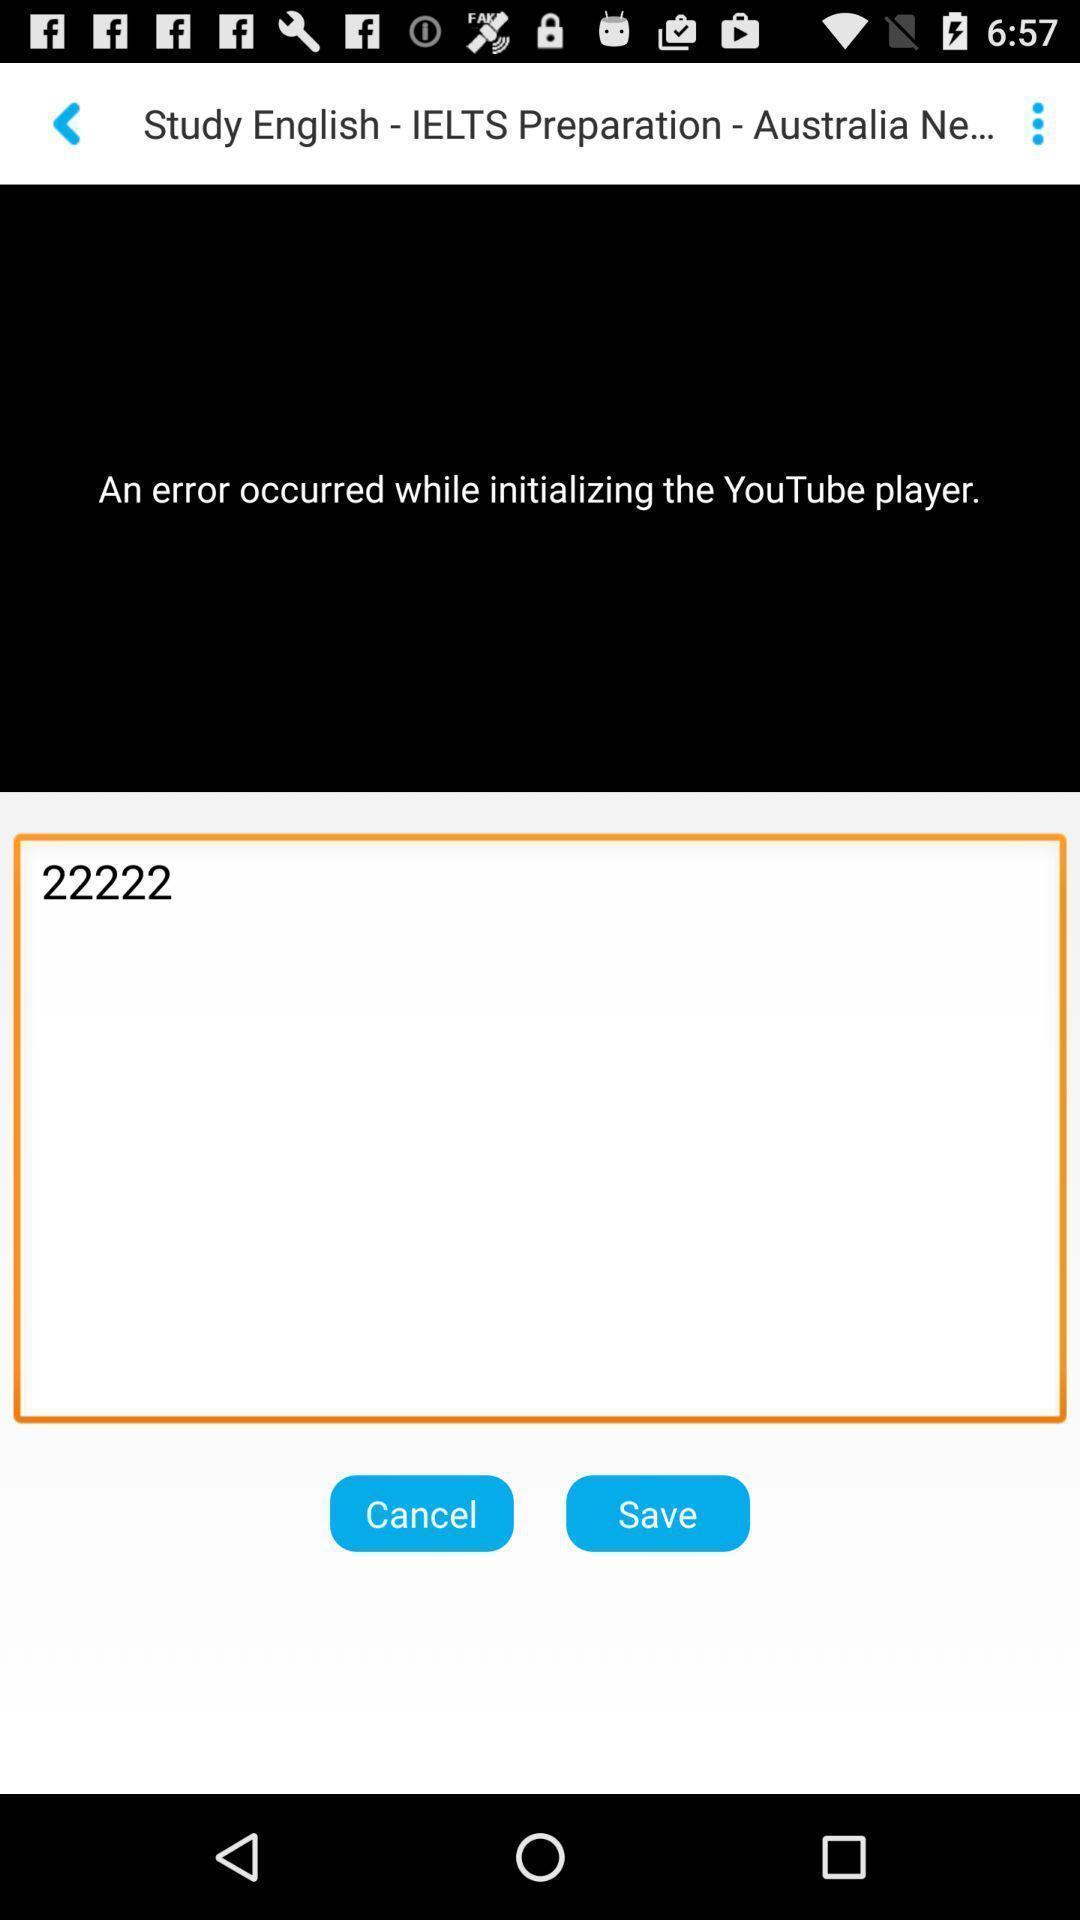Tell me about the visual elements in this screen capture. Study application with error update. 